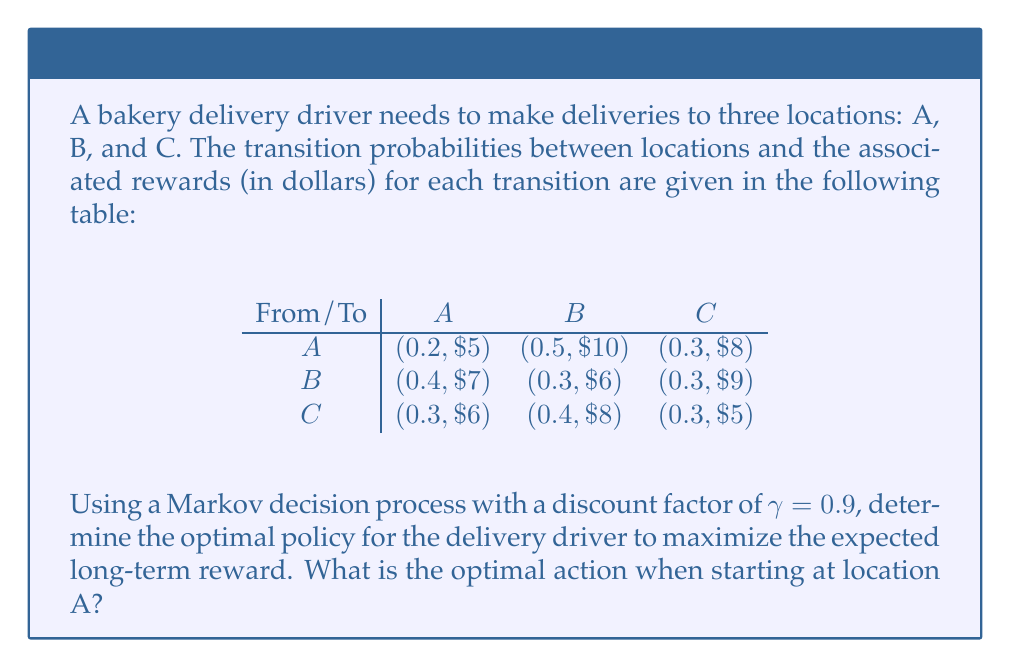What is the answer to this math problem? To solve this Markov decision process, we'll use the value iteration algorithm:

1. Initialize the value function $V(s)$ for each state to 0:
   $V(A) = V(B) = V(C) = 0$

2. For each iteration, update the value function for each state using the Bellman equation:
   $V(s) = \max_a \sum_{s'} P(s'|s,a) [R(s,a,s') + \gamma V(s')]$

3. Repeat step 2 until convergence (values change by less than a small threshold).

Let's perform a few iterations:

Iteration 1:
$V(A) = \max(0.2 \cdot 5 + 0.5 \cdot 10 + 0.3 \cdot 8) = 8.4$
$V(B) = \max(0.4 \cdot 7 + 0.3 \cdot 6 + 0.3 \cdot 9) = 7.3$
$V(C) = \max(0.3 \cdot 6 + 0.4 \cdot 8 + 0.3 \cdot 5) = 6.5$

Iteration 2:
$V(A) = \max(0.2 \cdot (5 + 0.9 \cdot 8.4) + 0.5 \cdot (10 + 0.9 \cdot 7.3) + 0.3 \cdot (8 + 0.9 \cdot 6.5)) = 15.13$
$V(B) = \max(0.4 \cdot (7 + 0.9 \cdot 8.4) + 0.3 \cdot (6 + 0.9 \cdot 7.3) + 0.3 \cdot (9 + 0.9 \cdot 6.5)) = 13.75$
$V(C) = \max(0.3 \cdot (6 + 0.9 \cdot 8.4) + 0.4 \cdot (8 + 0.9 \cdot 7.3) + 0.3 \cdot (5 + 0.9 \cdot 6.5)) = 13.24$

After several more iterations, the values converge to:
$V(A) \approx 18.76$
$V(B) \approx 17.38$
$V(C) \approx 16.87$

4. Determine the optimal policy by choosing the action that maximizes the expected value:

For state A:
$Q(A,A) = 0.2 \cdot (5 + 0.9 \cdot 18.76) + 0.5 \cdot (10 + 0.9 \cdot 17.38) + 0.3 \cdot (8 + 0.9 \cdot 16.87) = 18.76$

$Q(A,B)$ and $Q(A,C)$ would be calculated similarly, but they result in lower values.

Therefore, the optimal action when starting at location A is to choose the transition probabilities and rewards associated with row A in the given table.
Answer: Choose transition probabilities (0.2, 0.5, 0.3) with rewards ($5, $10, $8) for A, B, C respectively. 